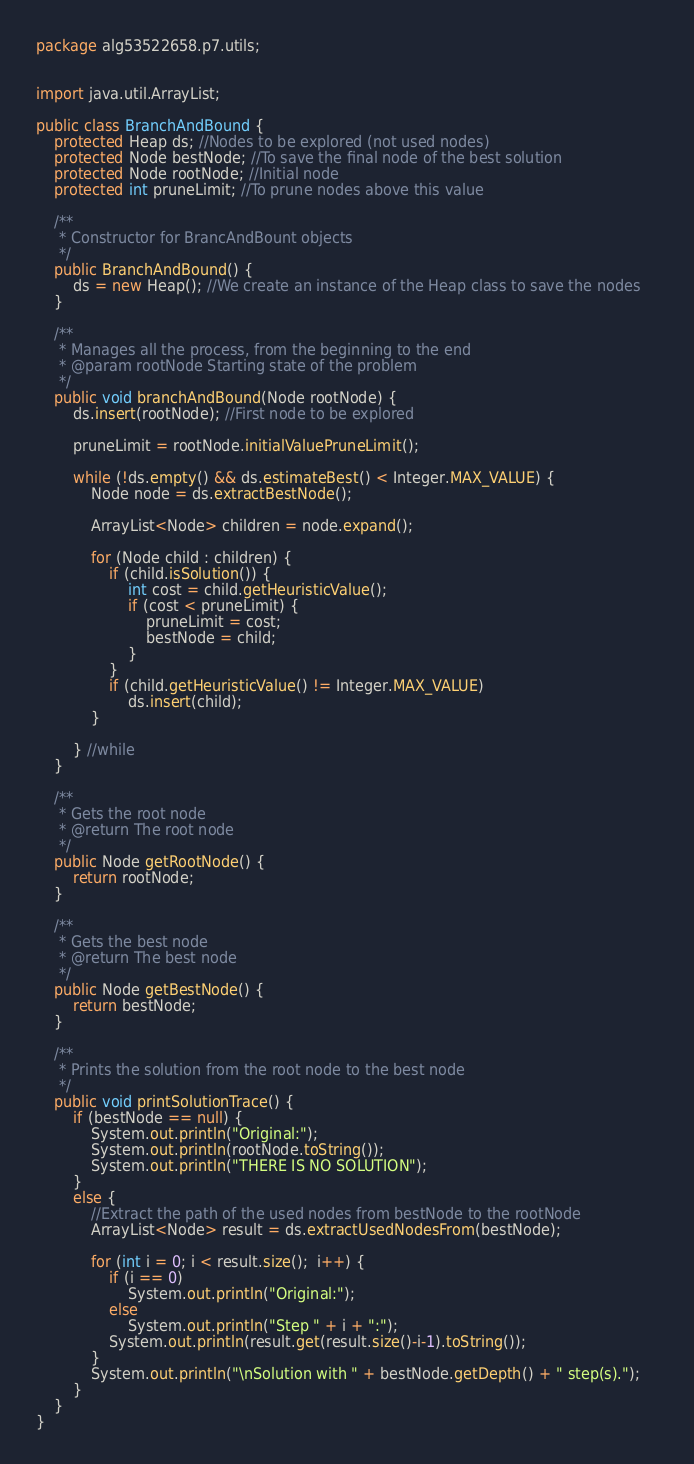<code> <loc_0><loc_0><loc_500><loc_500><_Java_>package alg53522658.p7.utils;


import java.util.ArrayList;

public class BranchAndBound {
	protected Heap ds; //Nodes to be explored (not used nodes)
	protected Node bestNode; //To save the final node of the best solution
	protected Node rootNode; //Initial node
	protected int pruneLimit; //To prune nodes above this value
	       
	/**
	 * Constructor for BrancAndBount objects
	 */
	public BranchAndBound() {
		ds = new Heap(); //We create an instance of the Heap class to save the nodes
	}
	      
	/**
	 * Manages all the process, from the beginning to the end
	 * @param rootNode Starting state of the problem
	 */
	public void branchAndBound(Node rootNode) { 
		ds.insert(rootNode); //First node to be explored
	
		pruneLimit = rootNode.initialValuePruneLimit();
		
		while (!ds.empty() && ds.estimateBest() < Integer.MAX_VALUE) {
			Node node = ds.extractBestNode();
			
			ArrayList<Node> children = node.expand(); 
						
			for (Node child : children) {
				if (child.isSolution()) {
					int cost = child.getHeuristicValue();
					if (cost < pruneLimit) {
						pruneLimit = cost;
						bestNode = child;
					} 
				}
				if (child.getHeuristicValue() != Integer.MAX_VALUE)
					ds.insert(child);
			}

		} //while
	}
		
	/**
	 * Gets the root node
	 * @return The root node
	 */
    public Node getRootNode() {
    	return rootNode;
    }
    
	/**
	 * Gets the best node
	 * @return The best node
	 */
    public Node getBestNode() {
    	return bestNode;
    }

    /**
     * Prints the solution from the root node to the best node
     */
    public void printSolutionTrace() {
    	if (bestNode == null) {
			System.out.println("Original:");
			System.out.println(rootNode.toString());
			System.out.println("THERE IS NO SOLUTION");
    	} 
    	else {
    		//Extract the path of the used nodes from bestNode to the rootNode
            ArrayList<Node> result = ds.extractUsedNodesFrom(bestNode);

            for (int i = 0; i < result.size();  i++) {
    			if (i == 0) 
    				System.out.println("Original:");
    			else 
    				System.out.println("Step " + i + ":");
    			System.out.println(result.get(result.size()-i-1).toString());
    	    }
            System.out.println("\nSolution with " + bestNode.getDepth() + " step(s).");	
    	}
    }
}
</code> 